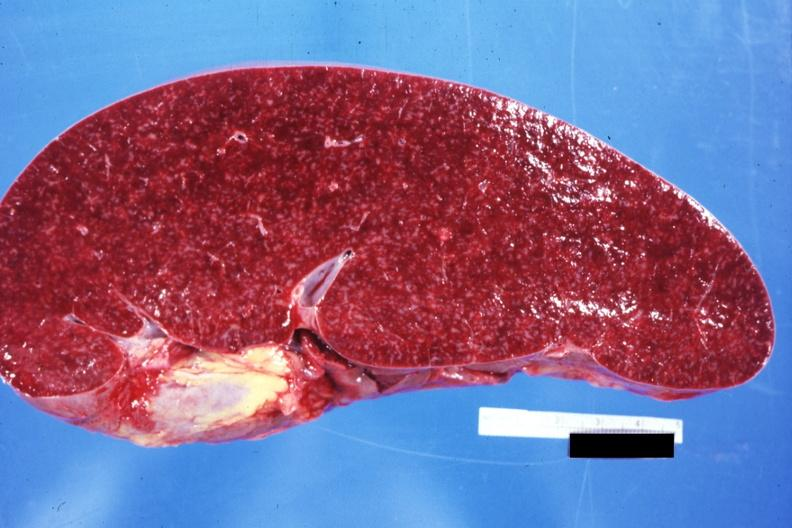what does size appear?
Answer the question using a single word or phrase. Normal see other sides this case 